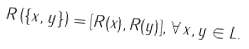<formula> <loc_0><loc_0><loc_500><loc_500>R \left ( \{ x , y \} \right ) = [ R ( x ) , R ( y ) ] , \, \forall \, x , y \in L .</formula> 